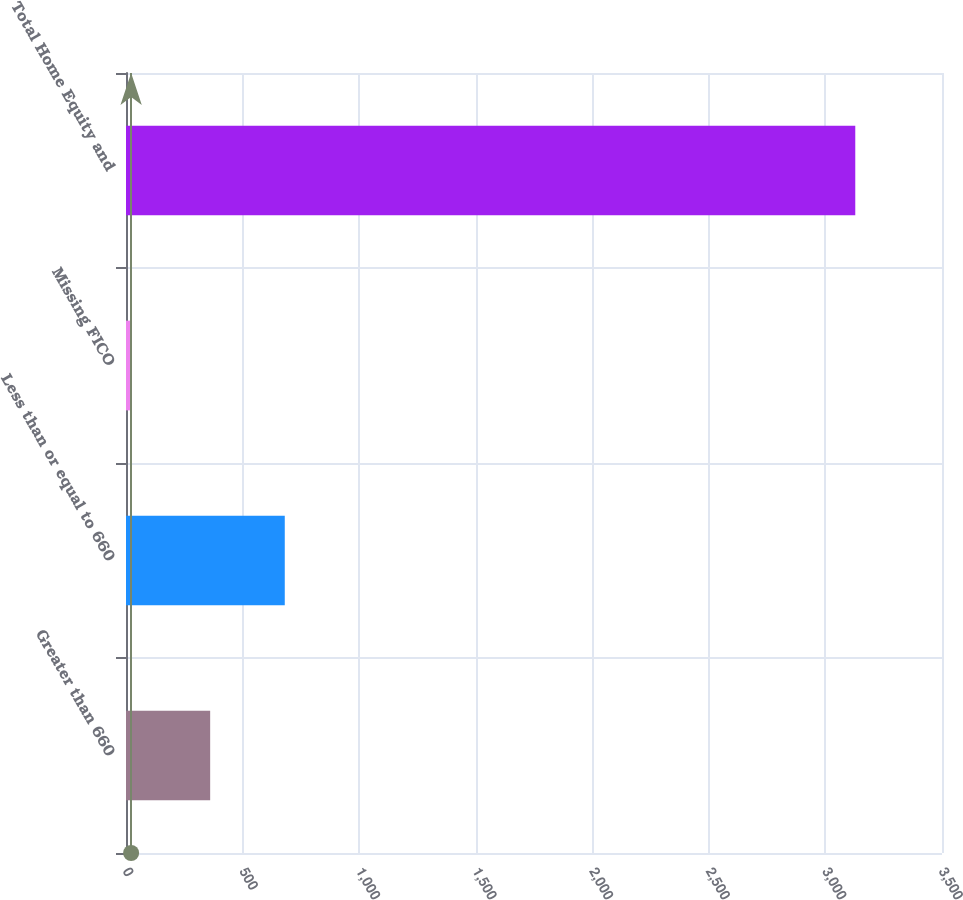<chart> <loc_0><loc_0><loc_500><loc_500><bar_chart><fcel>Greater than 660<fcel>Less than or equal to 660<fcel>Missing FICO<fcel>Total Home Equity and<nl><fcel>361<fcel>681<fcel>22<fcel>3128<nl></chart> 